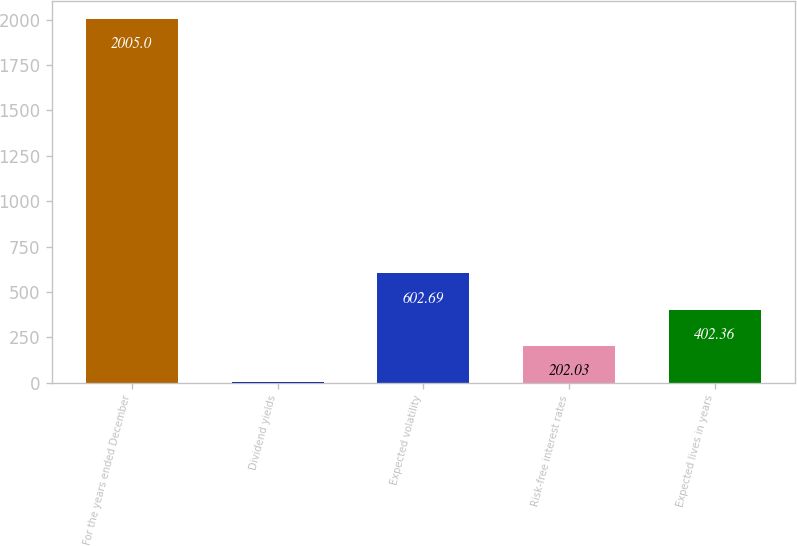<chart> <loc_0><loc_0><loc_500><loc_500><bar_chart><fcel>For the years ended December<fcel>Dividend yields<fcel>Expected volatility<fcel>Risk-free interest rates<fcel>Expected lives in years<nl><fcel>2005<fcel>1.7<fcel>602.69<fcel>202.03<fcel>402.36<nl></chart> 